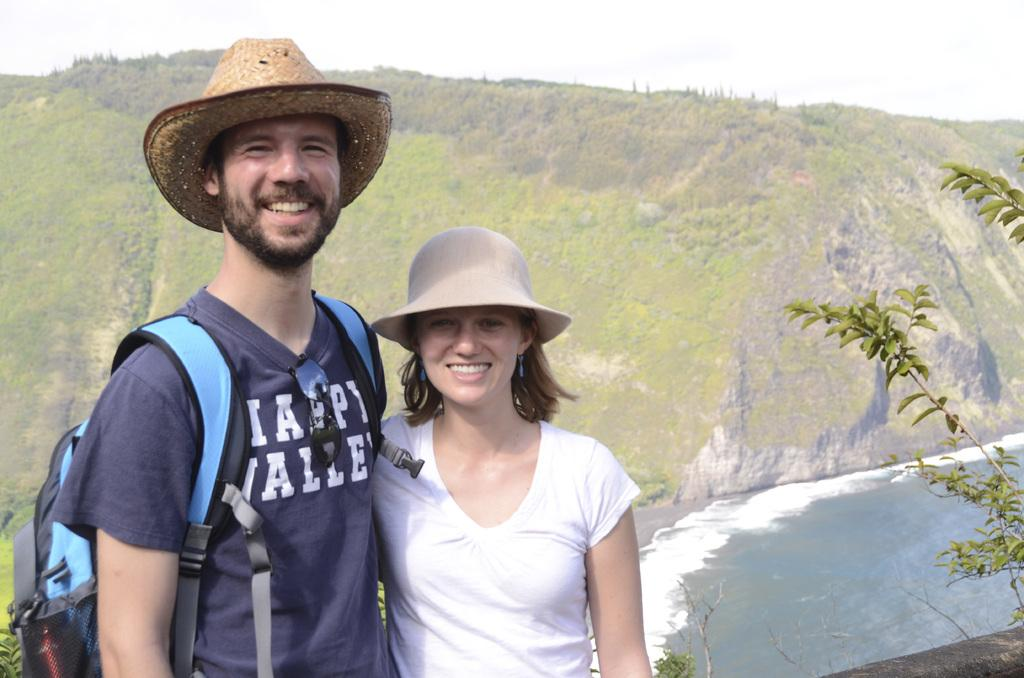<image>
Provide a brief description of the given image. Couple stands out field he is wearing a Nappy Valley shirt. 